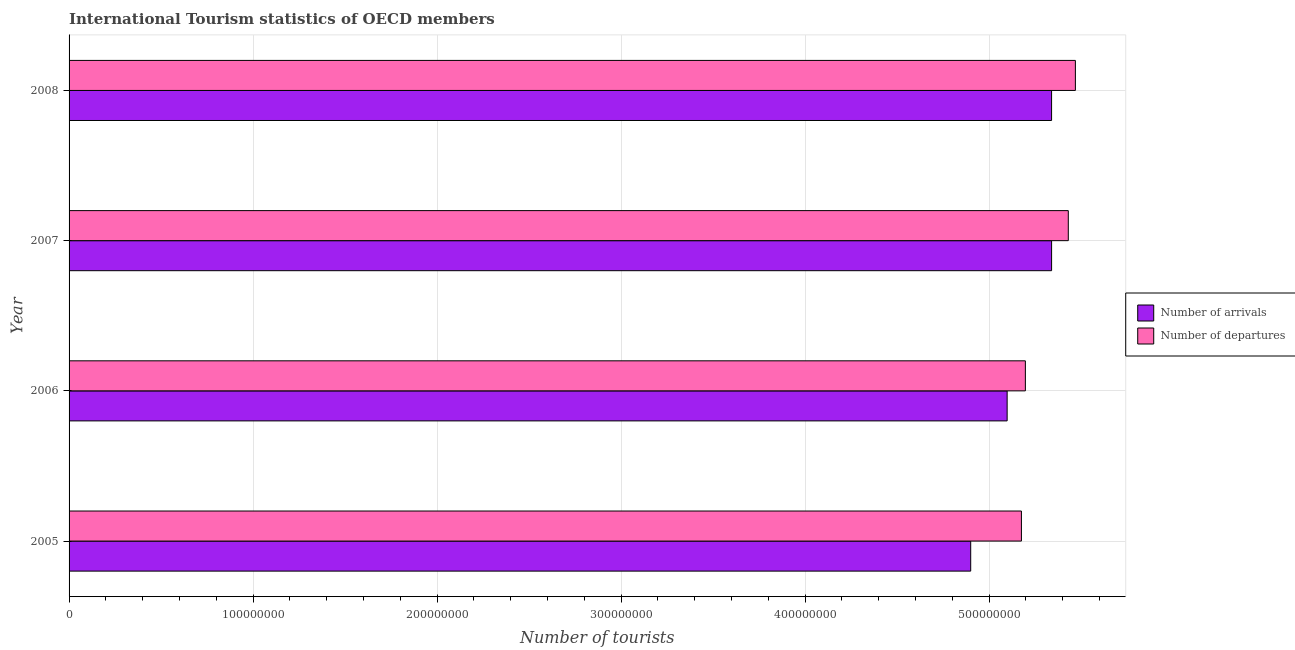How many different coloured bars are there?
Give a very brief answer. 2. Are the number of bars on each tick of the Y-axis equal?
Ensure brevity in your answer.  Yes. How many bars are there on the 1st tick from the bottom?
Keep it short and to the point. 2. What is the number of tourist departures in 2008?
Your response must be concise. 5.47e+08. Across all years, what is the maximum number of tourist arrivals?
Give a very brief answer. 5.34e+08. Across all years, what is the minimum number of tourist departures?
Ensure brevity in your answer.  5.18e+08. What is the total number of tourist arrivals in the graph?
Keep it short and to the point. 2.07e+09. What is the difference between the number of tourist departures in 2006 and that in 2008?
Offer a very short reply. -2.72e+07. What is the difference between the number of tourist departures in 2006 and the number of tourist arrivals in 2005?
Keep it short and to the point. 2.97e+07. What is the average number of tourist departures per year?
Keep it short and to the point. 5.32e+08. In the year 2008, what is the difference between the number of tourist departures and number of tourist arrivals?
Your answer should be very brief. 1.29e+07. In how many years, is the number of tourist departures greater than 440000000 ?
Your response must be concise. 4. Is the difference between the number of tourist departures in 2006 and 2008 greater than the difference between the number of tourist arrivals in 2006 and 2008?
Provide a short and direct response. No. What is the difference between the highest and the second highest number of tourist departures?
Your response must be concise. 3.86e+06. What is the difference between the highest and the lowest number of tourist departures?
Offer a very short reply. 2.93e+07. Is the sum of the number of tourist departures in 2005 and 2007 greater than the maximum number of tourist arrivals across all years?
Make the answer very short. Yes. What does the 2nd bar from the top in 2006 represents?
Your answer should be compact. Number of arrivals. What does the 2nd bar from the bottom in 2005 represents?
Give a very brief answer. Number of departures. How many bars are there?
Keep it short and to the point. 8. Are all the bars in the graph horizontal?
Provide a succinct answer. Yes. What is the difference between two consecutive major ticks on the X-axis?
Ensure brevity in your answer.  1.00e+08. Does the graph contain any zero values?
Give a very brief answer. No. Does the graph contain grids?
Keep it short and to the point. Yes. What is the title of the graph?
Give a very brief answer. International Tourism statistics of OECD members. What is the label or title of the X-axis?
Make the answer very short. Number of tourists. What is the Number of tourists of Number of arrivals in 2005?
Keep it short and to the point. 4.90e+08. What is the Number of tourists of Number of departures in 2005?
Make the answer very short. 5.18e+08. What is the Number of tourists of Number of arrivals in 2006?
Offer a very short reply. 5.10e+08. What is the Number of tourists in Number of departures in 2006?
Provide a short and direct response. 5.20e+08. What is the Number of tourists in Number of arrivals in 2007?
Make the answer very short. 5.34e+08. What is the Number of tourists in Number of departures in 2007?
Make the answer very short. 5.43e+08. What is the Number of tourists of Number of arrivals in 2008?
Your response must be concise. 5.34e+08. What is the Number of tourists of Number of departures in 2008?
Offer a terse response. 5.47e+08. Across all years, what is the maximum Number of tourists in Number of arrivals?
Your answer should be compact. 5.34e+08. Across all years, what is the maximum Number of tourists of Number of departures?
Your response must be concise. 5.47e+08. Across all years, what is the minimum Number of tourists in Number of arrivals?
Your response must be concise. 4.90e+08. Across all years, what is the minimum Number of tourists in Number of departures?
Your answer should be very brief. 5.18e+08. What is the total Number of tourists in Number of arrivals in the graph?
Make the answer very short. 2.07e+09. What is the total Number of tourists in Number of departures in the graph?
Provide a short and direct response. 2.13e+09. What is the difference between the Number of tourists of Number of arrivals in 2005 and that in 2006?
Provide a short and direct response. -1.98e+07. What is the difference between the Number of tourists of Number of departures in 2005 and that in 2006?
Your answer should be very brief. -2.15e+06. What is the difference between the Number of tourists of Number of arrivals in 2005 and that in 2007?
Provide a succinct answer. -4.40e+07. What is the difference between the Number of tourists of Number of departures in 2005 and that in 2007?
Your response must be concise. -2.55e+07. What is the difference between the Number of tourists of Number of arrivals in 2005 and that in 2008?
Offer a very short reply. -4.40e+07. What is the difference between the Number of tourists of Number of departures in 2005 and that in 2008?
Offer a terse response. -2.93e+07. What is the difference between the Number of tourists in Number of arrivals in 2006 and that in 2007?
Give a very brief answer. -2.42e+07. What is the difference between the Number of tourists of Number of departures in 2006 and that in 2007?
Provide a succinct answer. -2.33e+07. What is the difference between the Number of tourists in Number of arrivals in 2006 and that in 2008?
Offer a very short reply. -2.41e+07. What is the difference between the Number of tourists of Number of departures in 2006 and that in 2008?
Your response must be concise. -2.72e+07. What is the difference between the Number of tourists of Number of arrivals in 2007 and that in 2008?
Give a very brief answer. 5000. What is the difference between the Number of tourists of Number of departures in 2007 and that in 2008?
Provide a short and direct response. -3.86e+06. What is the difference between the Number of tourists of Number of arrivals in 2005 and the Number of tourists of Number of departures in 2006?
Your answer should be very brief. -2.97e+07. What is the difference between the Number of tourists in Number of arrivals in 2005 and the Number of tourists in Number of departures in 2007?
Keep it short and to the point. -5.30e+07. What is the difference between the Number of tourists of Number of arrivals in 2005 and the Number of tourists of Number of departures in 2008?
Keep it short and to the point. -5.69e+07. What is the difference between the Number of tourists of Number of arrivals in 2006 and the Number of tourists of Number of departures in 2007?
Ensure brevity in your answer.  -3.32e+07. What is the difference between the Number of tourists in Number of arrivals in 2006 and the Number of tourists in Number of departures in 2008?
Provide a succinct answer. -3.71e+07. What is the difference between the Number of tourists in Number of arrivals in 2007 and the Number of tourists in Number of departures in 2008?
Ensure brevity in your answer.  -1.29e+07. What is the average Number of tourists in Number of arrivals per year?
Ensure brevity in your answer.  5.17e+08. What is the average Number of tourists in Number of departures per year?
Make the answer very short. 5.32e+08. In the year 2005, what is the difference between the Number of tourists in Number of arrivals and Number of tourists in Number of departures?
Offer a terse response. -2.76e+07. In the year 2006, what is the difference between the Number of tourists in Number of arrivals and Number of tourists in Number of departures?
Your answer should be very brief. -9.91e+06. In the year 2007, what is the difference between the Number of tourists of Number of arrivals and Number of tourists of Number of departures?
Make the answer very short. -9.08e+06. In the year 2008, what is the difference between the Number of tourists of Number of arrivals and Number of tourists of Number of departures?
Offer a terse response. -1.29e+07. What is the ratio of the Number of tourists of Number of arrivals in 2005 to that in 2006?
Give a very brief answer. 0.96. What is the ratio of the Number of tourists of Number of arrivals in 2005 to that in 2007?
Your response must be concise. 0.92. What is the ratio of the Number of tourists in Number of departures in 2005 to that in 2007?
Your response must be concise. 0.95. What is the ratio of the Number of tourists of Number of arrivals in 2005 to that in 2008?
Ensure brevity in your answer.  0.92. What is the ratio of the Number of tourists in Number of departures in 2005 to that in 2008?
Your response must be concise. 0.95. What is the ratio of the Number of tourists of Number of arrivals in 2006 to that in 2007?
Provide a succinct answer. 0.95. What is the ratio of the Number of tourists of Number of departures in 2006 to that in 2007?
Provide a short and direct response. 0.96. What is the ratio of the Number of tourists in Number of arrivals in 2006 to that in 2008?
Your response must be concise. 0.95. What is the ratio of the Number of tourists of Number of departures in 2006 to that in 2008?
Your answer should be very brief. 0.95. What is the ratio of the Number of tourists of Number of arrivals in 2007 to that in 2008?
Your response must be concise. 1. What is the difference between the highest and the second highest Number of tourists in Number of departures?
Ensure brevity in your answer.  3.86e+06. What is the difference between the highest and the lowest Number of tourists of Number of arrivals?
Offer a terse response. 4.40e+07. What is the difference between the highest and the lowest Number of tourists in Number of departures?
Make the answer very short. 2.93e+07. 